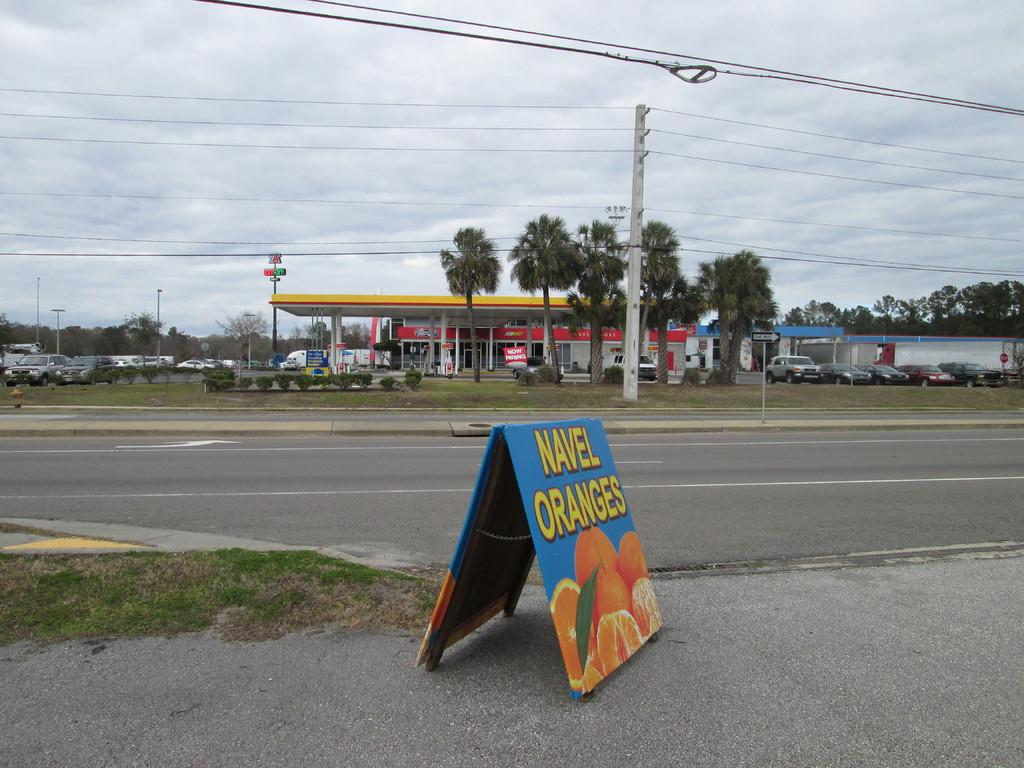<image>
Present a compact description of the photo's key features. A gas station with a yellow roof, a road and then a sign that is blue with oranges on it and in yellow letters it says NAVEL ORANGES. 